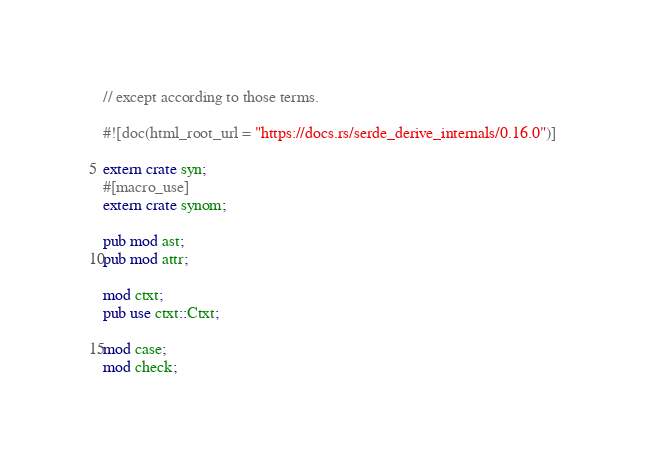<code> <loc_0><loc_0><loc_500><loc_500><_Rust_>// except according to those terms.

#![doc(html_root_url = "https://docs.rs/serde_derive_internals/0.16.0")]

extern crate syn;
#[macro_use]
extern crate synom;

pub mod ast;
pub mod attr;

mod ctxt;
pub use ctxt::Ctxt;

mod case;
mod check;
</code> 